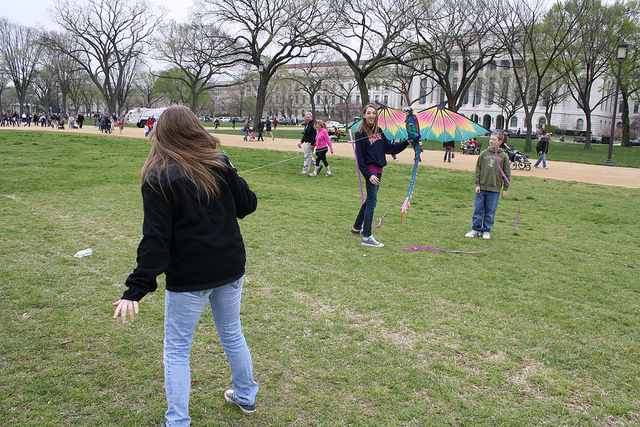Can you tell me what the colorful object that people are playing with is called, and how it's used? The colorful object is a kite, a tethered object that flies in the air when manipulated correctly. It requires wind to lift off and is usually flown for recreational purposes. The person holding the string controls the kite's movements against the wind, which can be both a skillful and enjoyable activity. 